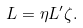<formula> <loc_0><loc_0><loc_500><loc_500>L = \eta L ^ { \prime } \zeta .</formula> 